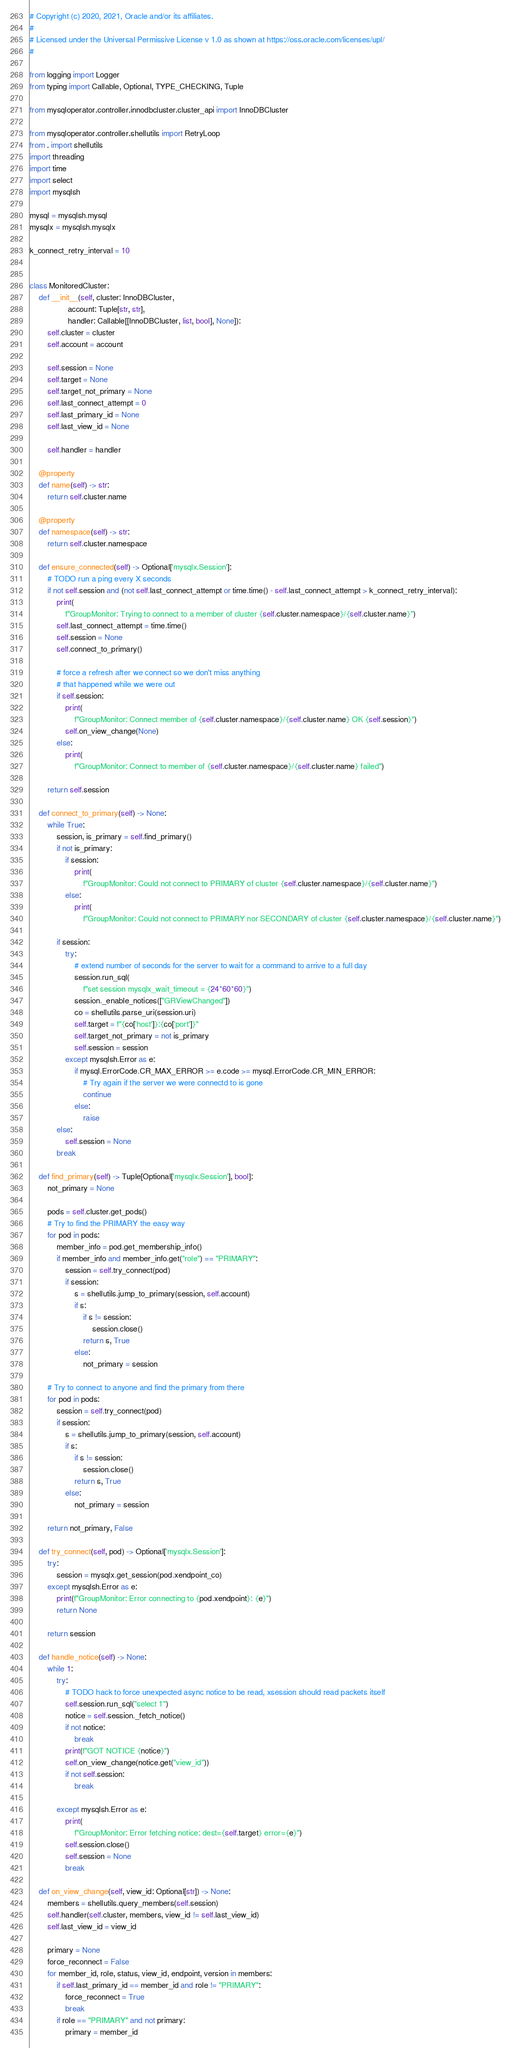<code> <loc_0><loc_0><loc_500><loc_500><_Python_># Copyright (c) 2020, 2021, Oracle and/or its affiliates.
#
# Licensed under the Universal Permissive License v 1.0 as shown at https://oss.oracle.com/licenses/upl/
#

from logging import Logger
from typing import Callable, Optional, TYPE_CHECKING, Tuple

from mysqloperator.controller.innodbcluster.cluster_api import InnoDBCluster

from mysqloperator.controller.shellutils import RetryLoop
from . import shellutils
import threading
import time
import select
import mysqlsh

mysql = mysqlsh.mysql
mysqlx = mysqlsh.mysqlx

k_connect_retry_interval = 10


class MonitoredCluster:
    def __init__(self, cluster: InnoDBCluster,
                 account: Tuple[str, str],
                 handler: Callable[[InnoDBCluster, list, bool], None]):
        self.cluster = cluster
        self.account = account

        self.session = None
        self.target = None
        self.target_not_primary = None
        self.last_connect_attempt = 0
        self.last_primary_id = None
        self.last_view_id = None

        self.handler = handler

    @property
    def name(self) -> str:
        return self.cluster.name

    @property
    def namespace(self) -> str:
        return self.cluster.namespace

    def ensure_connected(self) -> Optional['mysqlx.Session']:
        # TODO run a ping every X seconds
        if not self.session and (not self.last_connect_attempt or time.time() - self.last_connect_attempt > k_connect_retry_interval):
            print(
                f"GroupMonitor: Trying to connect to a member of cluster {self.cluster.namespace}/{self.cluster.name}")
            self.last_connect_attempt = time.time()
            self.session = None
            self.connect_to_primary()

            # force a refresh after we connect so we don't miss anything
            # that happened while we were out
            if self.session:
                print(
                    f"GroupMonitor: Connect member of {self.cluster.namespace}/{self.cluster.name} OK {self.session}")
                self.on_view_change(None)
            else:
                print(
                    f"GroupMonitor: Connect to member of {self.cluster.namespace}/{self.cluster.name} failed")

        return self.session

    def connect_to_primary(self) -> None:
        while True:
            session, is_primary = self.find_primary()
            if not is_primary:
                if session:
                    print(
                        f"GroupMonitor: Could not connect to PRIMARY of cluster {self.cluster.namespace}/{self.cluster.name}")
                else:
                    print(
                        f"GroupMonitor: Could not connect to PRIMARY nor SECONDARY of cluster {self.cluster.namespace}/{self.cluster.name}")

            if session:
                try:
                    # extend number of seconds for the server to wait for a command to arrive to a full day
                    session.run_sql(
                        f"set session mysqlx_wait_timeout = {24*60*60}")
                    session._enable_notices(["GRViewChanged"])
                    co = shellutils.parse_uri(session.uri)
                    self.target = f"{co['host']}:{co['port']}"
                    self.target_not_primary = not is_primary
                    self.session = session
                except mysqlsh.Error as e:
                    if mysql.ErrorCode.CR_MAX_ERROR >= e.code >= mysql.ErrorCode.CR_MIN_ERROR:
                        # Try again if the server we were connectd to is gone
                        continue
                    else:
                        raise
            else:
                self.session = None
            break

    def find_primary(self) -> Tuple[Optional['mysqlx.Session'], bool]:
        not_primary = None

        pods = self.cluster.get_pods()
        # Try to find the PRIMARY the easy way
        for pod in pods:
            member_info = pod.get_membership_info()
            if member_info and member_info.get("role") == "PRIMARY":
                session = self.try_connect(pod)
                if session:
                    s = shellutils.jump_to_primary(session, self.account)
                    if s:
                        if s != session:
                            session.close()
                        return s, True
                    else:
                        not_primary = session

        # Try to connect to anyone and find the primary from there
        for pod in pods:
            session = self.try_connect(pod)
            if session:
                s = shellutils.jump_to_primary(session, self.account)
                if s:
                    if s != session:
                        session.close()
                    return s, True
                else:
                    not_primary = session

        return not_primary, False

    def try_connect(self, pod) -> Optional['mysqlx.Session']:
        try:
            session = mysqlx.get_session(pod.xendpoint_co)
        except mysqlsh.Error as e:
            print(f"GroupMonitor: Error connecting to {pod.xendpoint}: {e}")
            return None

        return session

    def handle_notice(self) -> None:
        while 1:
            try:
                # TODO hack to force unexpected async notice to be read, xsession should read packets itself
                self.session.run_sql("select 1")
                notice = self.session._fetch_notice()
                if not notice:
                    break
                print(f"GOT NOTICE {notice}")
                self.on_view_change(notice.get("view_id"))
                if not self.session:
                    break

            except mysqlsh.Error as e:
                print(
                    f"GroupMonitor: Error fetching notice: dest={self.target} error={e}")
                self.session.close()
                self.session = None
                break

    def on_view_change(self, view_id: Optional[str]) -> None:
        members = shellutils.query_members(self.session)
        self.handler(self.cluster, members, view_id != self.last_view_id)
        self.last_view_id = view_id

        primary = None
        force_reconnect = False
        for member_id, role, status, view_id, endpoint, version in members:
            if self.last_primary_id == member_id and role != "PRIMARY":
                force_reconnect = True
                break
            if role == "PRIMARY" and not primary:
                primary = member_id
</code> 